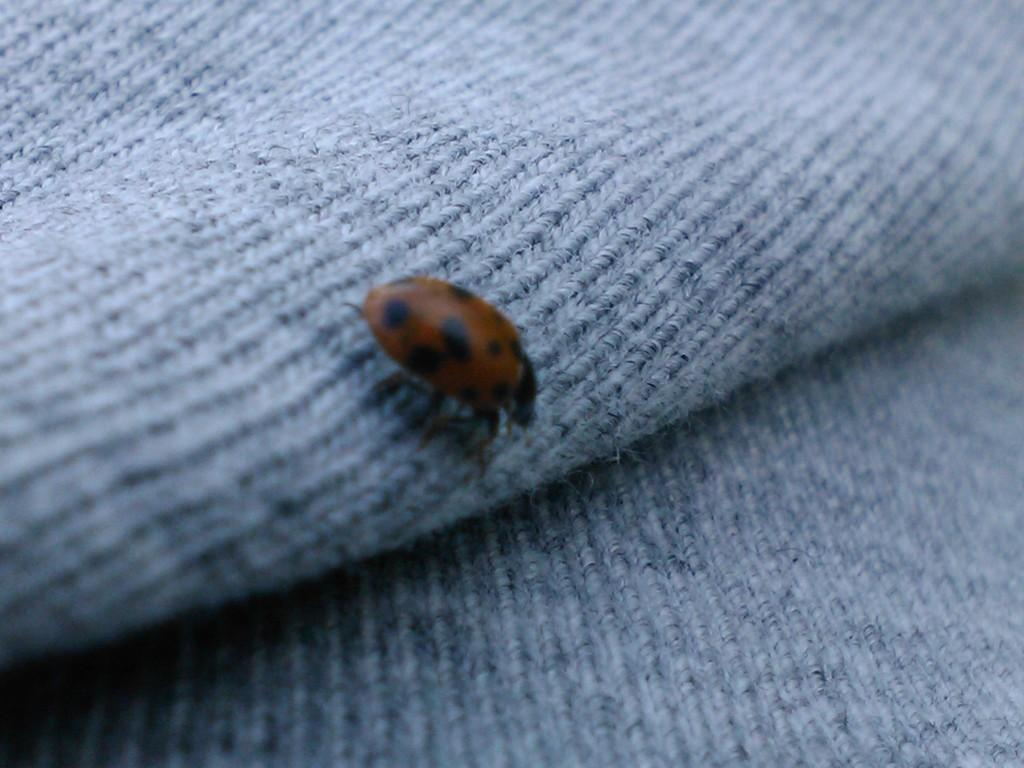What type of creature can be seen in the image? There is an insect in the image. Can you describe the background of the image? There is an object in the background of the image. What type of plants can be seen growing on the thread in the image? There is no thread or plants present in the image; it only features an insect and an object in the background. 